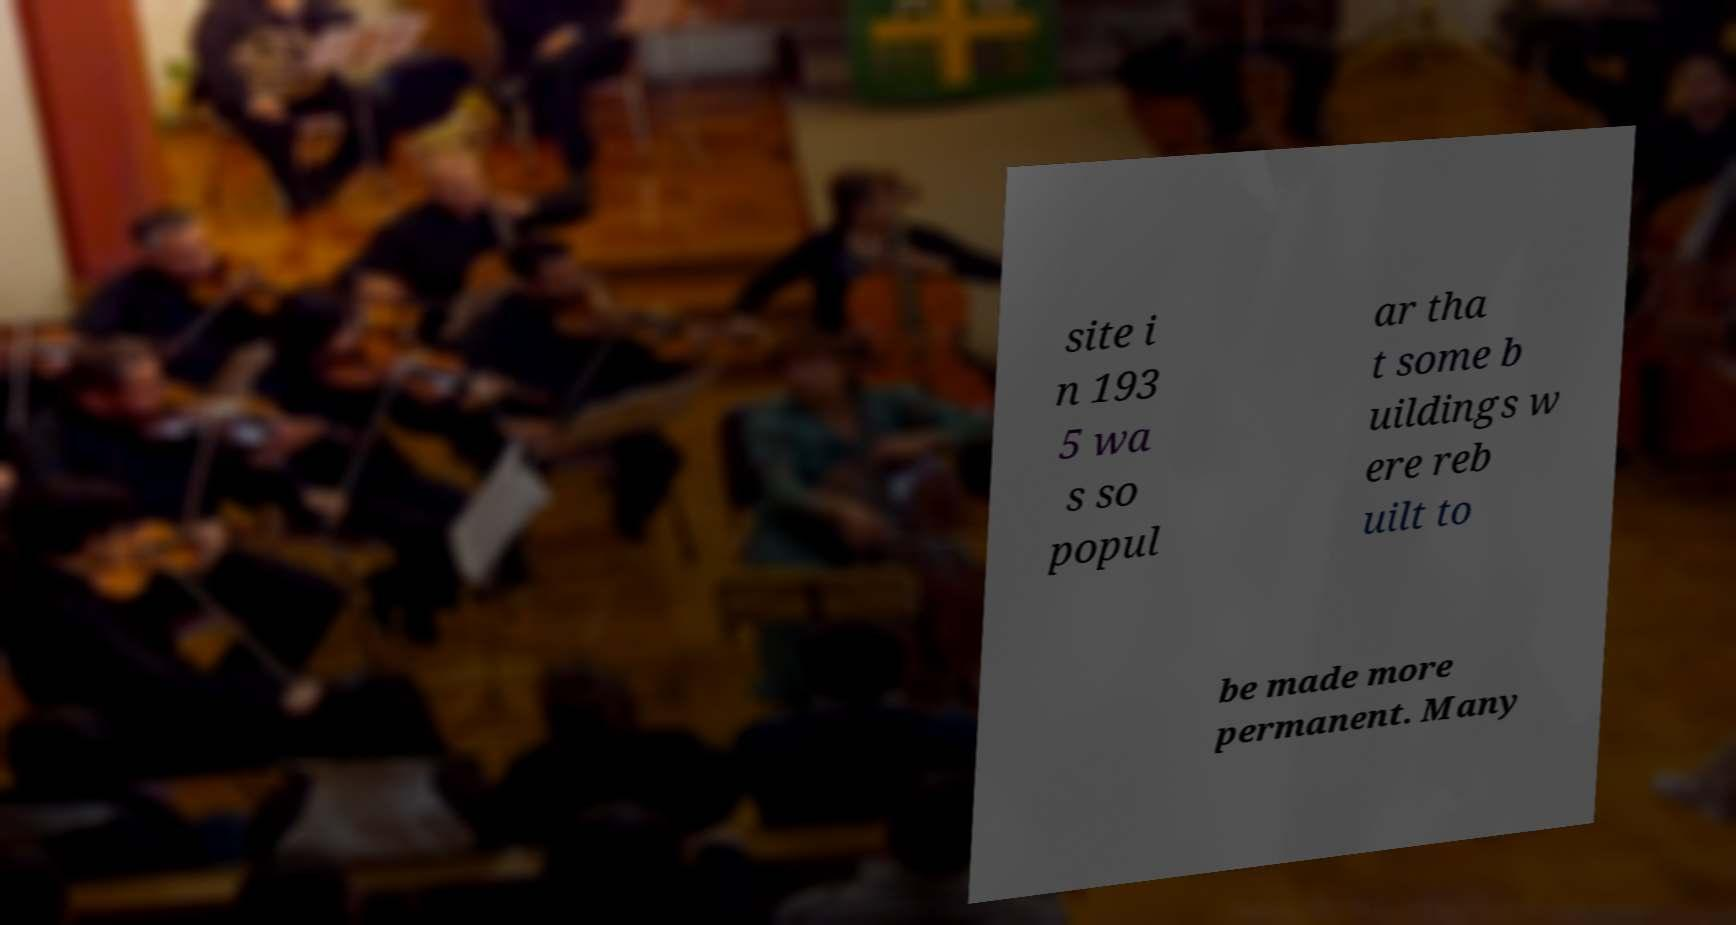I need the written content from this picture converted into text. Can you do that? site i n 193 5 wa s so popul ar tha t some b uildings w ere reb uilt to be made more permanent. Many 